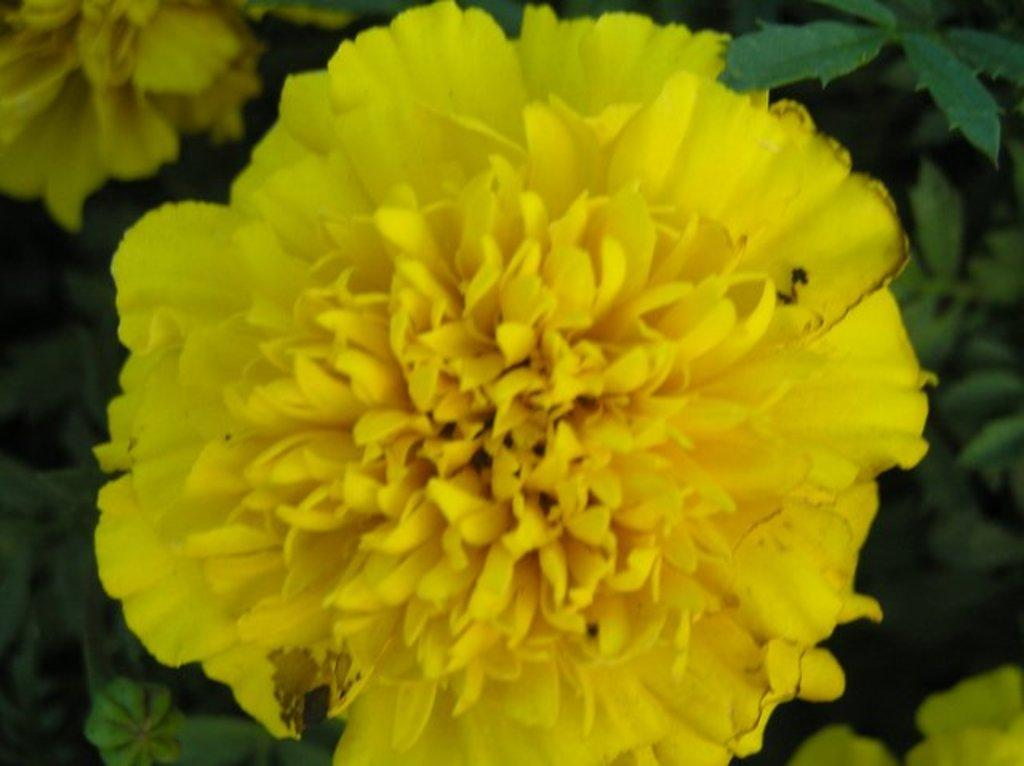What is the main subject of the image? There is a flower in the image. Can you describe the flower's origin? The flower belongs to a plant. Can you tell me how many lakes are visible in the image? There are no lakes visible in the image; it features a flower. What type of action does the flower perform in the image? Flowers do not perform actions like sneezing or rolling; they are stationary parts of plants. 